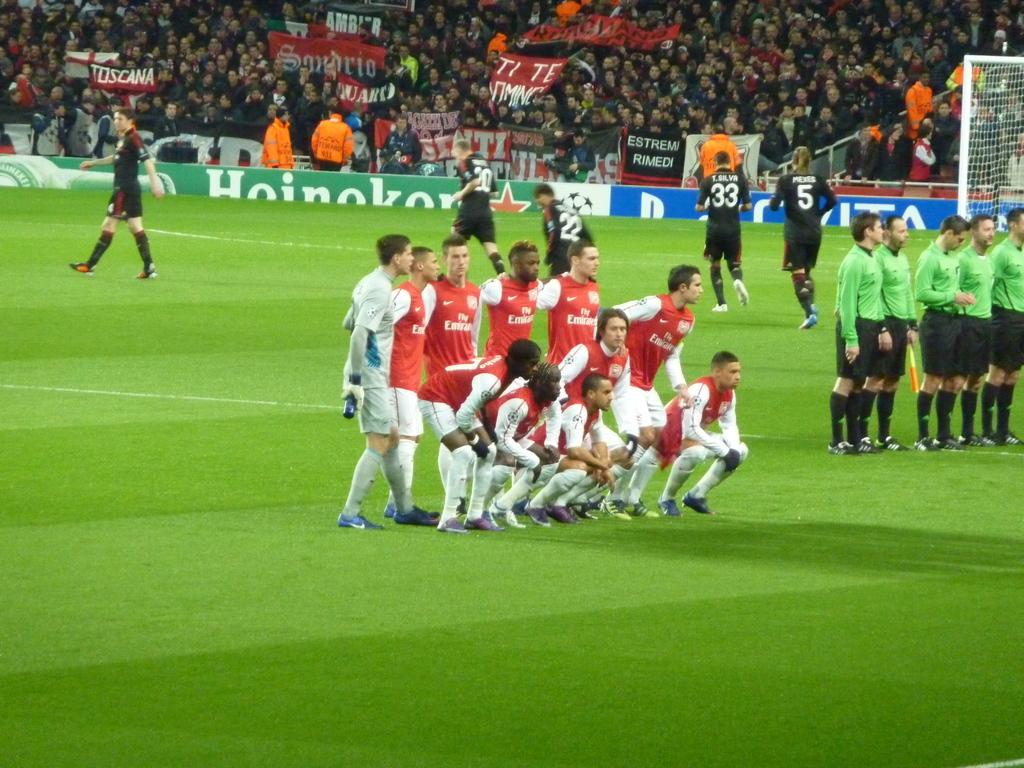<image>
Write a terse but informative summary of the picture. a soccer team in red jerseys with a sponsor of fly emirates on the front 